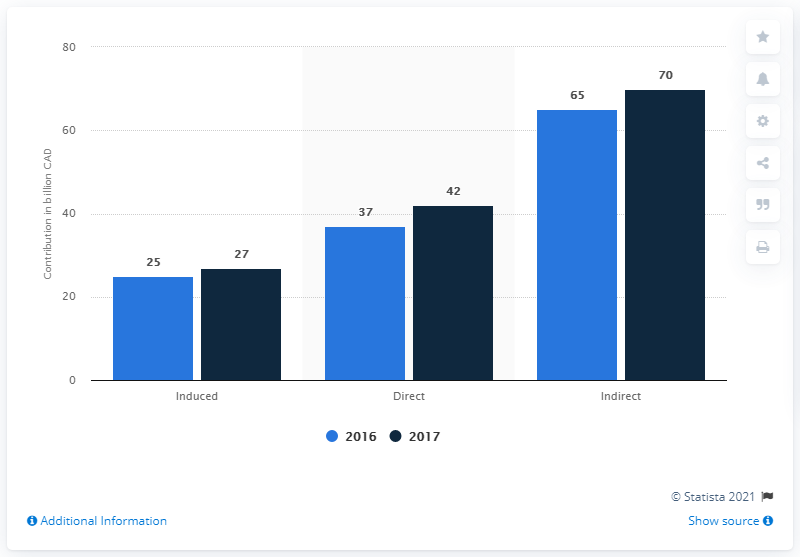Highlight a few significant elements in this photo. In 2017, the travel and tourism industry directly contributed CAD 42 billion to the Canadian economy. 